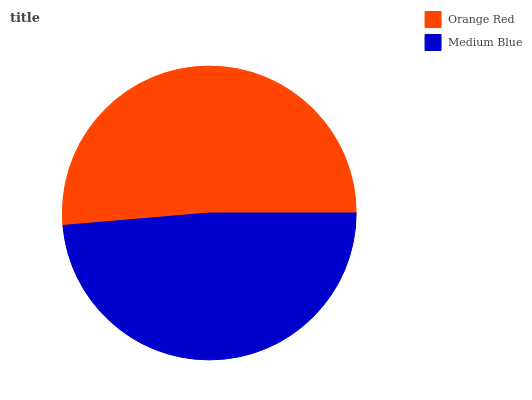Is Medium Blue the minimum?
Answer yes or no. Yes. Is Orange Red the maximum?
Answer yes or no. Yes. Is Medium Blue the maximum?
Answer yes or no. No. Is Orange Red greater than Medium Blue?
Answer yes or no. Yes. Is Medium Blue less than Orange Red?
Answer yes or no. Yes. Is Medium Blue greater than Orange Red?
Answer yes or no. No. Is Orange Red less than Medium Blue?
Answer yes or no. No. Is Orange Red the high median?
Answer yes or no. Yes. Is Medium Blue the low median?
Answer yes or no. Yes. Is Medium Blue the high median?
Answer yes or no. No. Is Orange Red the low median?
Answer yes or no. No. 